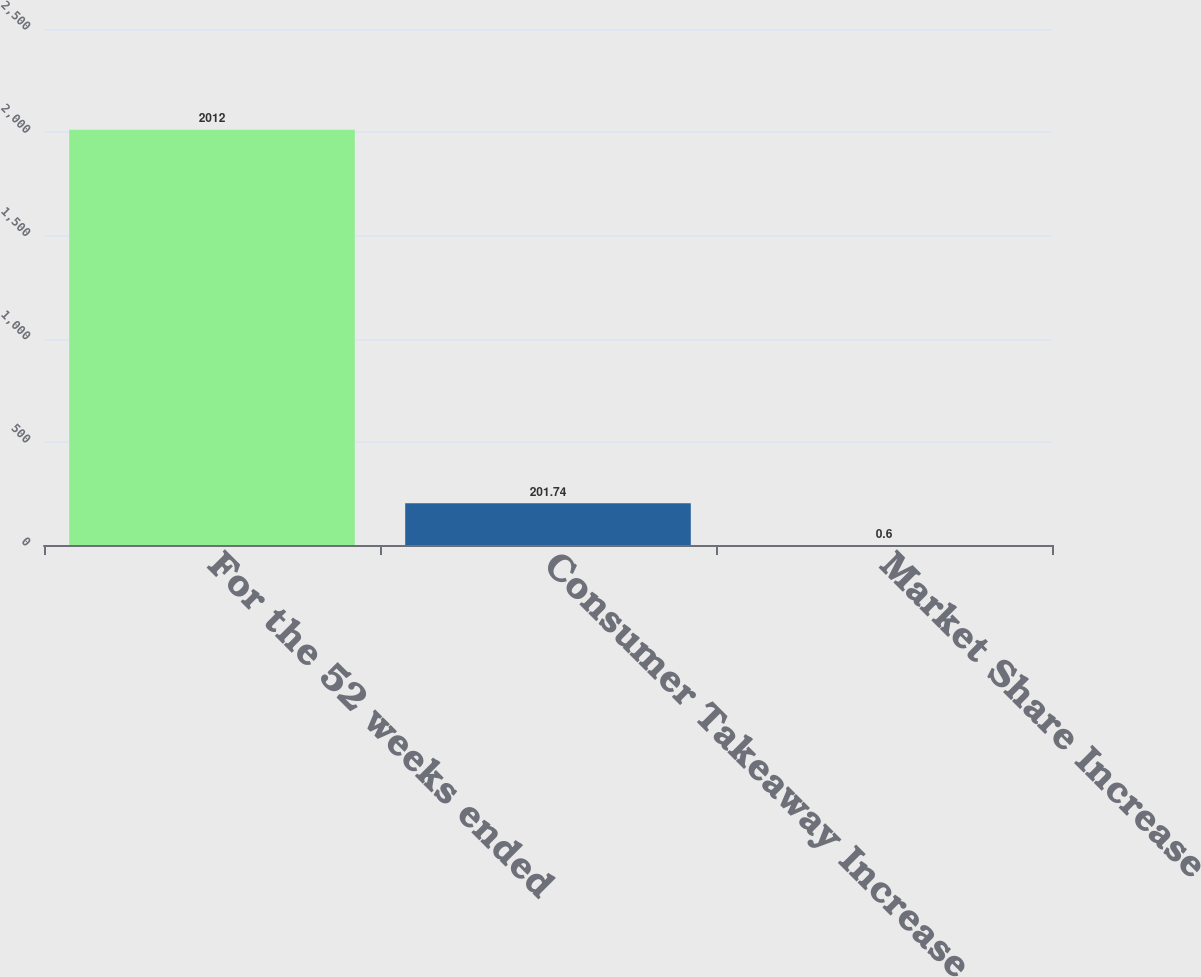<chart> <loc_0><loc_0><loc_500><loc_500><bar_chart><fcel>For the 52 weeks ended<fcel>Consumer Takeaway Increase<fcel>Market Share Increase<nl><fcel>2012<fcel>201.74<fcel>0.6<nl></chart> 